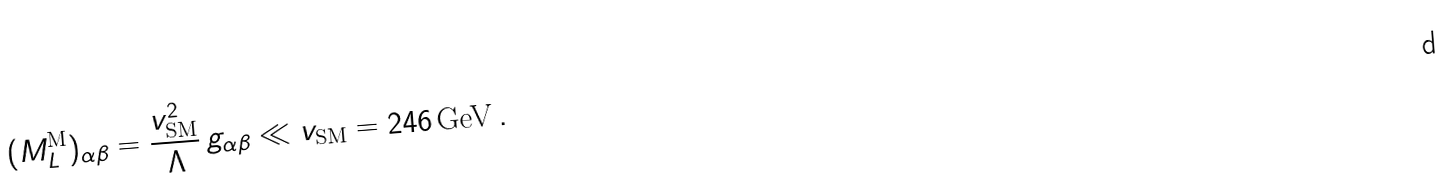Convert formula to latex. <formula><loc_0><loc_0><loc_500><loc_500>( M _ { L } ^ { \text {M} } ) _ { \alpha \beta } = \frac { v _ { \text {SM} } ^ { 2 } } { \Lambda } \, g _ { \alpha \beta } \ll v _ { \text {SM} } = 2 4 6 \, \text {GeV} \, .</formula> 